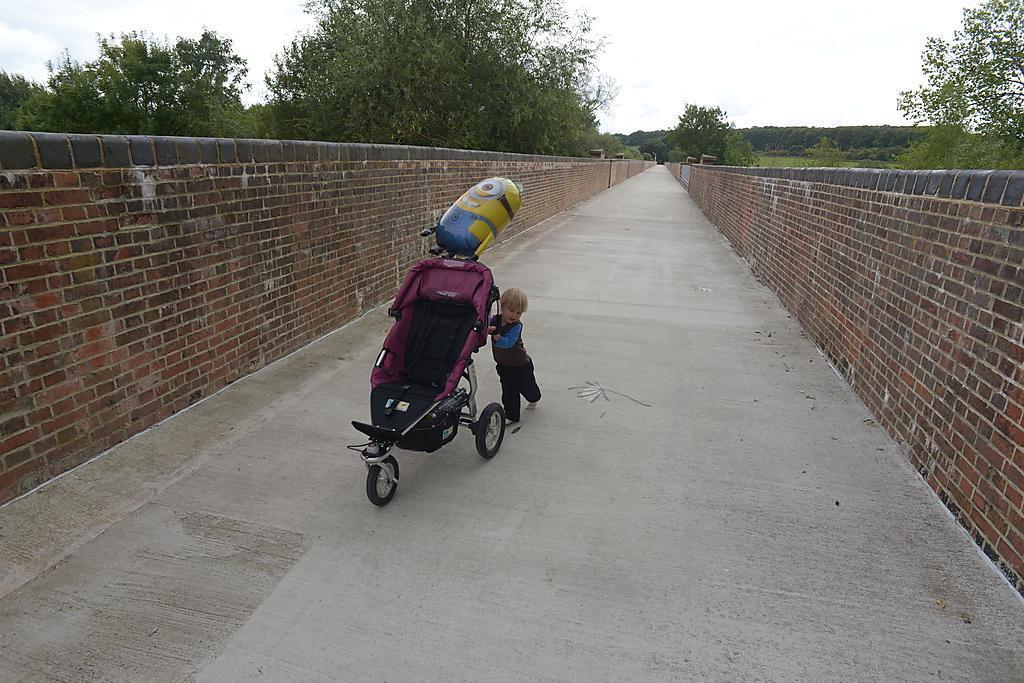Describe this image in one or two sentences. In the middle of the image a kid is walking and holding a stroller. Behind him we can see two walls. Behind the walls we can see some trees. At the top of the image we can see some clouds in the sky. 